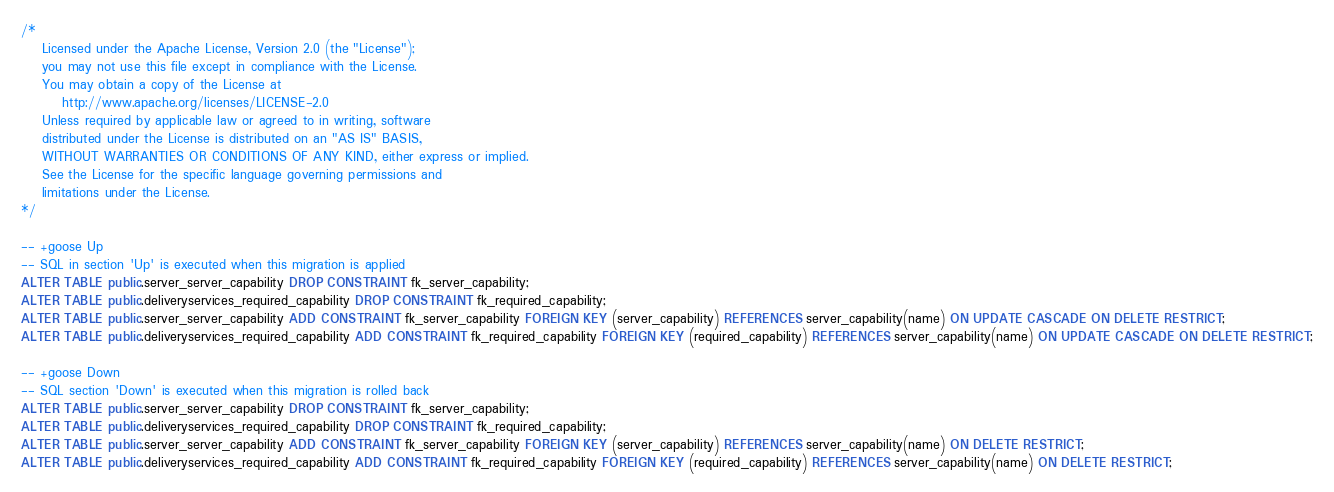<code> <loc_0><loc_0><loc_500><loc_500><_SQL_>/*
    Licensed under the Apache License, Version 2.0 (the "License");
    you may not use this file except in compliance with the License.
    You may obtain a copy of the License at
        http://www.apache.org/licenses/LICENSE-2.0
    Unless required by applicable law or agreed to in writing, software
    distributed under the License is distributed on an "AS IS" BASIS,
    WITHOUT WARRANTIES OR CONDITIONS OF ANY KIND, either express or implied.
    See the License for the specific language governing permissions and
    limitations under the License.
*/

-- +goose Up
-- SQL in section 'Up' is executed when this migration is applied
ALTER TABLE public.server_server_capability DROP CONSTRAINT fk_server_capability;
ALTER TABLE public.deliveryservices_required_capability DROP CONSTRAINT fk_required_capability;
ALTER TABLE public.server_server_capability ADD CONSTRAINT fk_server_capability FOREIGN KEY (server_capability) REFERENCES server_capability(name) ON UPDATE CASCADE ON DELETE RESTRICT;
ALTER TABLE public.deliveryservices_required_capability ADD CONSTRAINT fk_required_capability FOREIGN KEY (required_capability) REFERENCES server_capability(name) ON UPDATE CASCADE ON DELETE RESTRICT;

-- +goose Down
-- SQL section 'Down' is executed when this migration is rolled back
ALTER TABLE public.server_server_capability DROP CONSTRAINT fk_server_capability;
ALTER TABLE public.deliveryservices_required_capability DROP CONSTRAINT fk_required_capability;
ALTER TABLE public.server_server_capability ADD CONSTRAINT fk_server_capability FOREIGN KEY (server_capability) REFERENCES server_capability(name) ON DELETE RESTRICT;
ALTER TABLE public.deliveryservices_required_capability ADD CONSTRAINT fk_required_capability FOREIGN KEY (required_capability) REFERENCES server_capability(name) ON DELETE RESTRICT;
</code> 